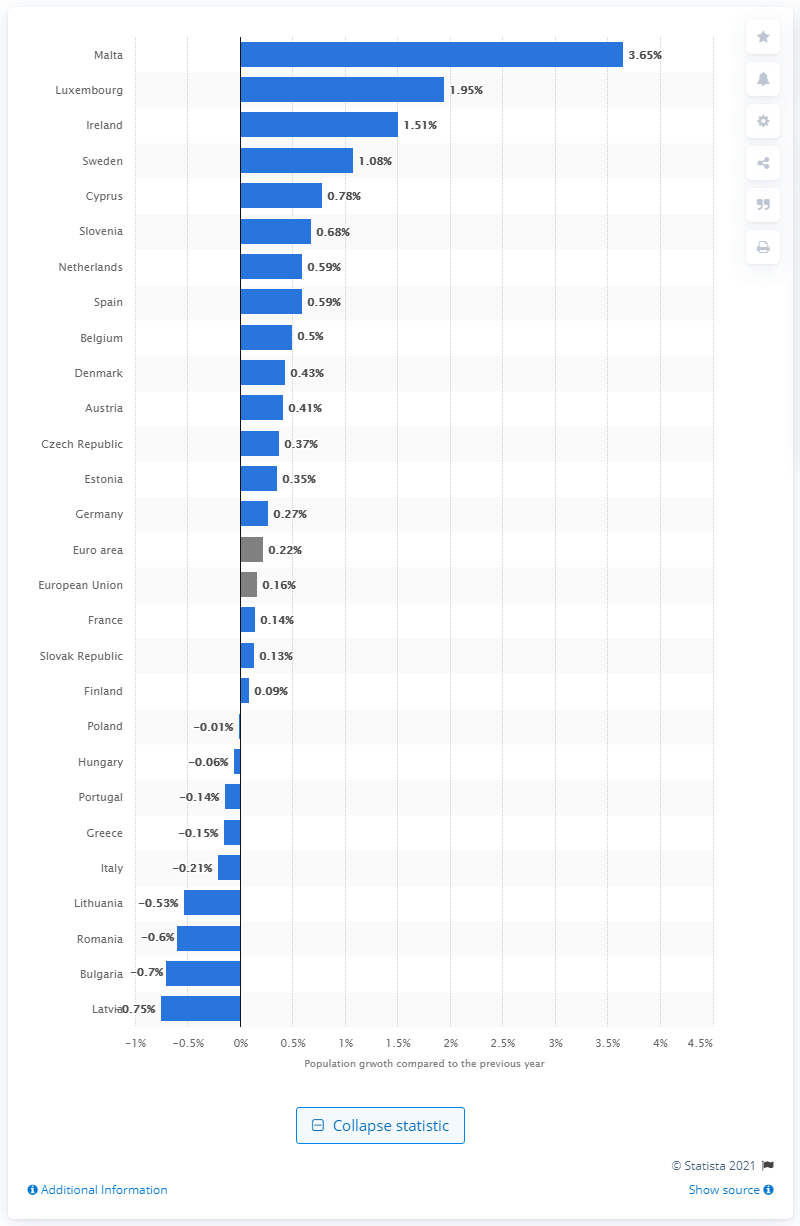Highlight a few significant elements in this photo. Luxembourg's population grew by 1.95% in the year 2019. 